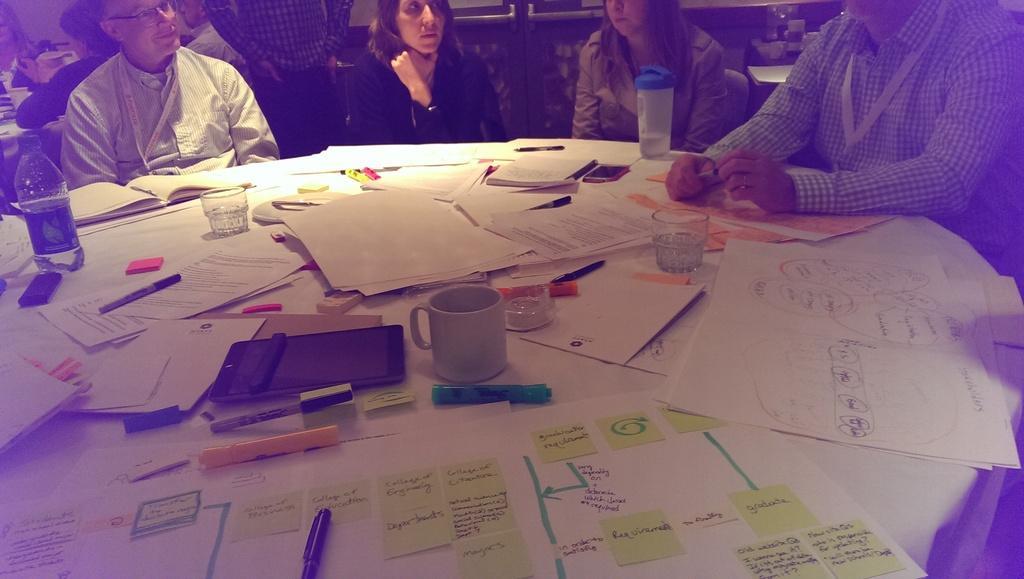Describe this image in one or two sentences. in the picture there are people sitting around the table,on the table there are many items such as papers glasses,lens,mobile phones,bottles e. t. c. 